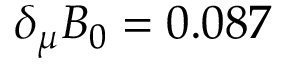Convert formula to latex. <formula><loc_0><loc_0><loc_500><loc_500>\delta _ { \mu } B _ { 0 } = 0 . 0 8 7</formula> 